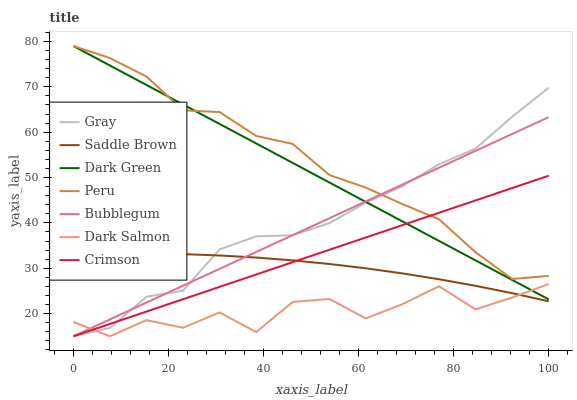Does Dark Salmon have the minimum area under the curve?
Answer yes or no. Yes. Does Peru have the maximum area under the curve?
Answer yes or no. Yes. Does Bubblegum have the minimum area under the curve?
Answer yes or no. No. Does Bubblegum have the maximum area under the curve?
Answer yes or no. No. Is Bubblegum the smoothest?
Answer yes or no. Yes. Is Dark Salmon the roughest?
Answer yes or no. Yes. Is Dark Salmon the smoothest?
Answer yes or no. No. Is Bubblegum the roughest?
Answer yes or no. No. Does Gray have the lowest value?
Answer yes or no. Yes. Does Peru have the lowest value?
Answer yes or no. No. Does Dark Green have the highest value?
Answer yes or no. Yes. Does Bubblegum have the highest value?
Answer yes or no. No. Is Saddle Brown less than Dark Green?
Answer yes or no. Yes. Is Dark Green greater than Saddle Brown?
Answer yes or no. Yes. Does Gray intersect Dark Salmon?
Answer yes or no. Yes. Is Gray less than Dark Salmon?
Answer yes or no. No. Is Gray greater than Dark Salmon?
Answer yes or no. No. Does Saddle Brown intersect Dark Green?
Answer yes or no. No. 